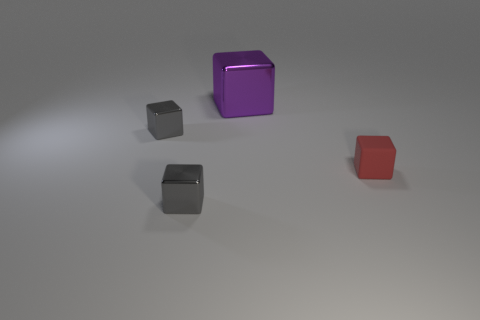Subtract all blue spheres. How many gray cubes are left? 2 Subtract all large cubes. How many cubes are left? 3 Subtract all purple cubes. How many cubes are left? 3 Subtract all cyan blocks. Subtract all purple cylinders. How many blocks are left? 4 Add 1 big cubes. How many objects exist? 5 Subtract all yellow rubber cylinders. Subtract all purple blocks. How many objects are left? 3 Add 1 gray objects. How many gray objects are left? 3 Add 1 tiny metal objects. How many tiny metal objects exist? 3 Subtract 0 yellow cubes. How many objects are left? 4 